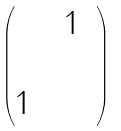Convert formula to latex. <formula><loc_0><loc_0><loc_500><loc_500>\begin{pmatrix} & & 1 \\ & & & \\ 1 & & \end{pmatrix}</formula> 